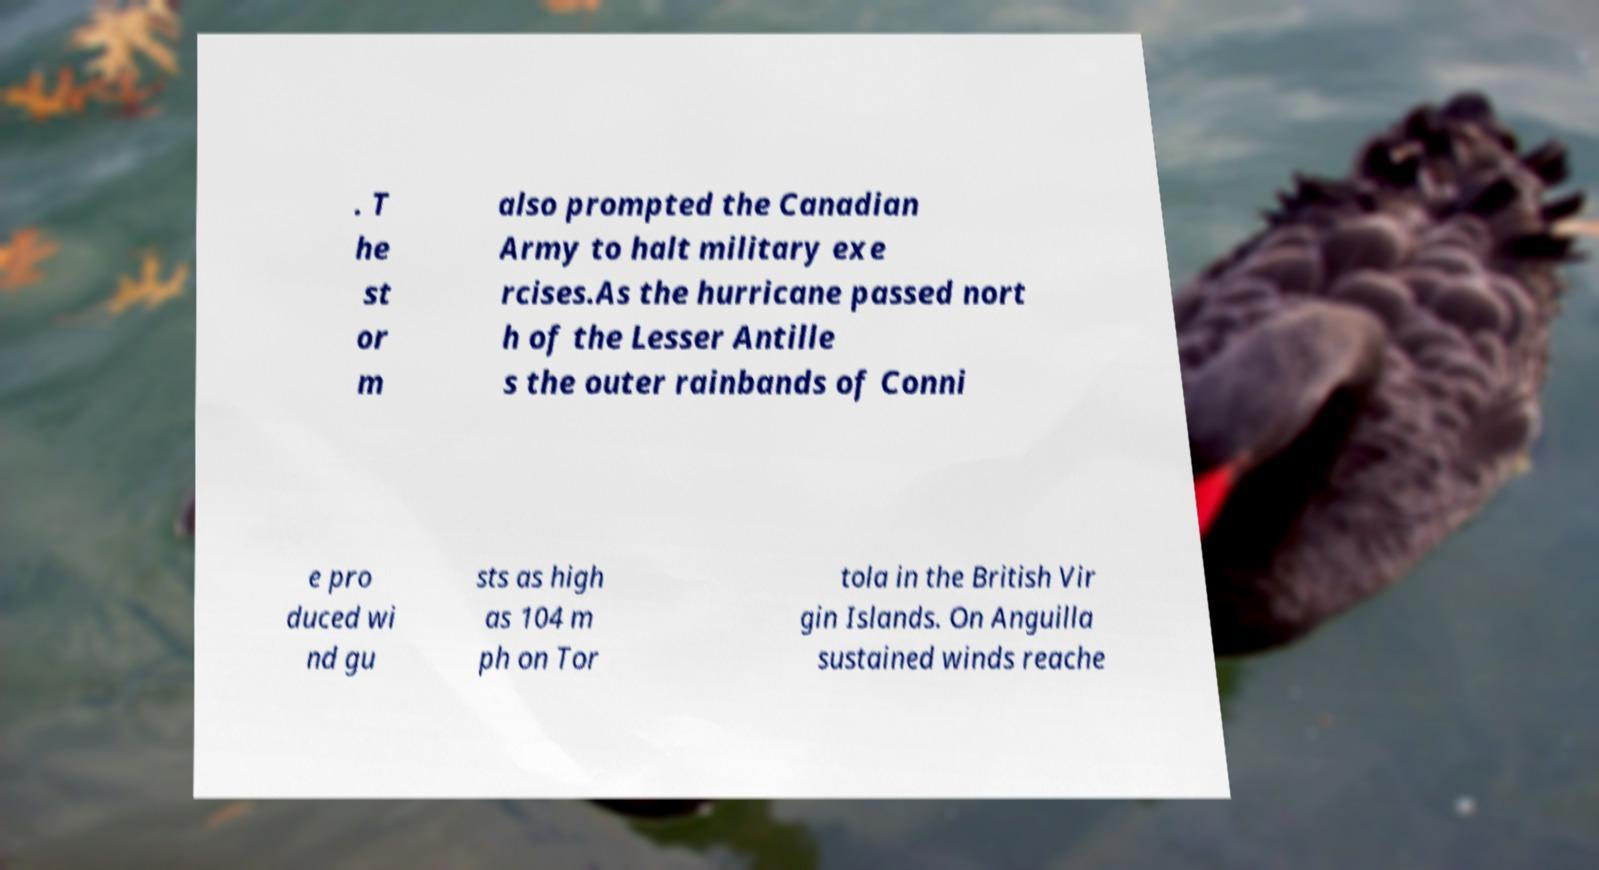Can you read and provide the text displayed in the image?This photo seems to have some interesting text. Can you extract and type it out for me? . T he st or m also prompted the Canadian Army to halt military exe rcises.As the hurricane passed nort h of the Lesser Antille s the outer rainbands of Conni e pro duced wi nd gu sts as high as 104 m ph on Tor tola in the British Vir gin Islands. On Anguilla sustained winds reache 